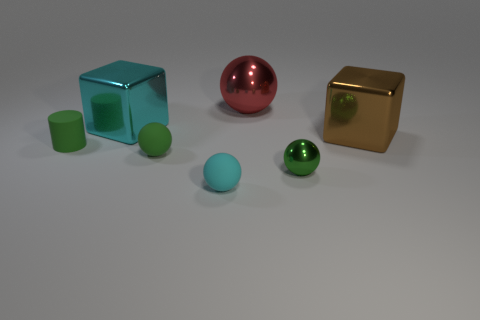How many other things are the same shape as the brown object?
Provide a short and direct response. 1. Is the number of small cyan rubber spheres to the left of the small cyan ball the same as the number of red metal balls in front of the small green metal object?
Your response must be concise. Yes. How many cylinders are cyan things or big cyan metallic things?
Provide a succinct answer. 0. What number of green things are made of the same material as the big red thing?
Offer a very short reply. 1. What shape is the tiny metal object that is the same color as the matte cylinder?
Provide a short and direct response. Sphere. There is a big object that is on the right side of the green matte ball and left of the brown cube; what is its material?
Make the answer very short. Metal. There is a tiny green rubber object that is in front of the green cylinder; what is its shape?
Offer a very short reply. Sphere. What shape is the large metal object behind the shiny cube that is on the left side of the cyan matte object?
Provide a succinct answer. Sphere. Is there a tiny yellow metallic thing of the same shape as the large brown metallic object?
Make the answer very short. No. There is a cyan thing that is the same size as the red thing; what shape is it?
Keep it short and to the point. Cube. 